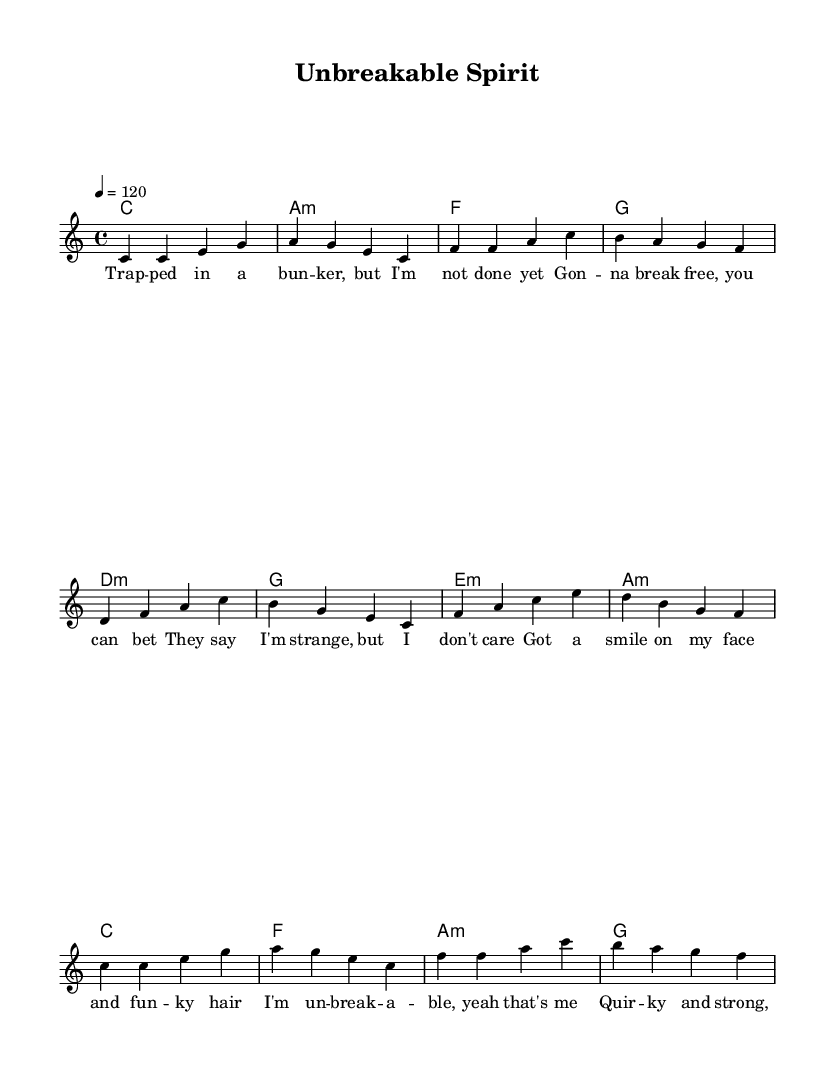What is the key signature of this music? The key signature displayed is C major, which indicates there are no sharps or flats.
Answer: C major What is the time signature of this piece? The time signature is indicated as 4/4, which means there are four beats in a measure and a quarter note receives one beat.
Answer: 4/4 What is the tempo marking for this music? The tempo is set at 120 beats per minute, which is indicated in the score.
Answer: 120 What are the chords used in the chorus? The chorus chords listed are C, F, A minor, and G, which are simplified harmonic structures for this section.
Answer: C, F, A minor, G What is the theme conveyed in the lyrics of the verse? The lyrics illustrate feelings of perseverance and determination despite being faced with challenges, highlighting a sense of resilience.
Answer: Perseverance and determination How many distinct sections does this piece have? The music has three distinct sections: Verse, Prechorus, and Chorus. Each section has its own musical and lyrical characteristics.
Answer: Three What stylistic elements are present in the lyrics that are typical of R&B? The lyrics display a combination of humor and quirky elements while addressing personal strength and overcoming adversity, which are common themes in R&B music.
Answer: Quirky elements addressing personal strength 